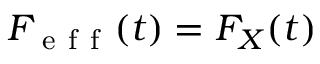<formula> <loc_0><loc_0><loc_500><loc_500>F _ { e f f } ( t ) = F _ { X } ( t )</formula> 